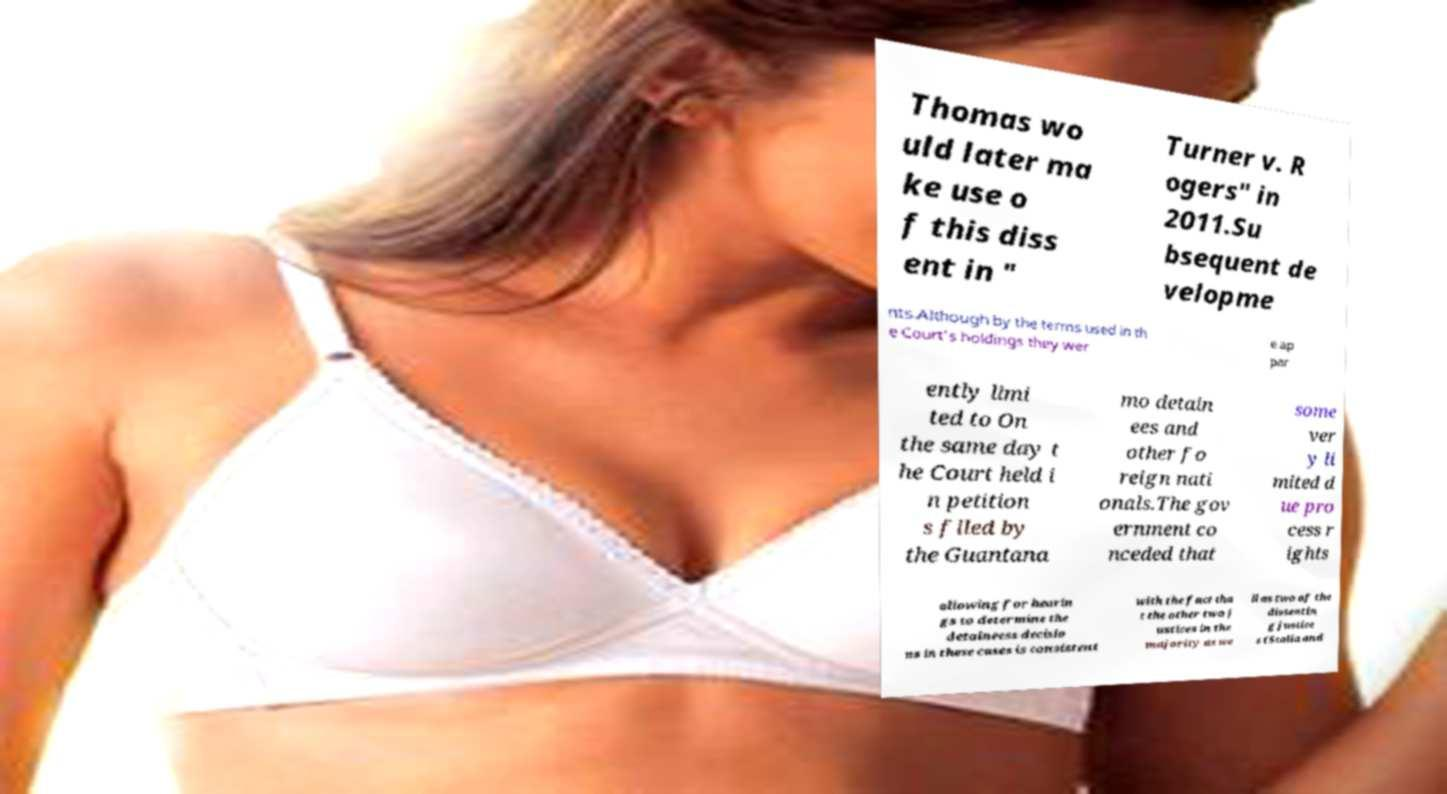Could you assist in decoding the text presented in this image and type it out clearly? Thomas wo uld later ma ke use o f this diss ent in " Turner v. R ogers" in 2011.Su bsequent de velopme nts.Although by the terms used in th e Court's holdings they wer e ap par ently limi ted to On the same day t he Court held i n petition s filed by the Guantana mo detain ees and other fo reign nati onals.The gov ernment co nceded that some ver y li mited d ue pro cess r ights allowing for hearin gs to determine the detaineess decisio ns in these cases is consistent with the fact tha t the other two j ustices in the majority as we ll as two of the dissentin g justice s (Scalia and 